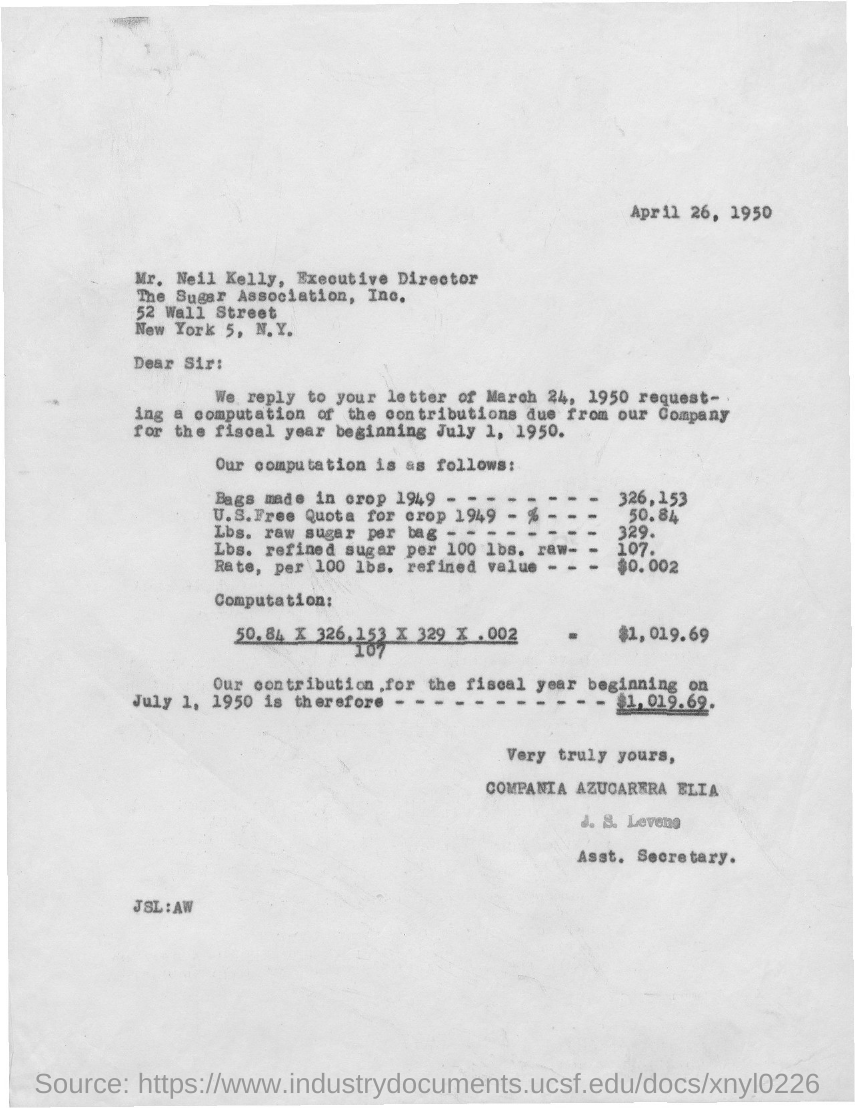Give some essential details in this illustration. The letter is dated April 26, 1950. J.S. Levene is the Assistant Secretary. Mr. Neil Kelly holds the position of Executive Director. The Sugar Association, Inc. is located at 52 Wall Street. 